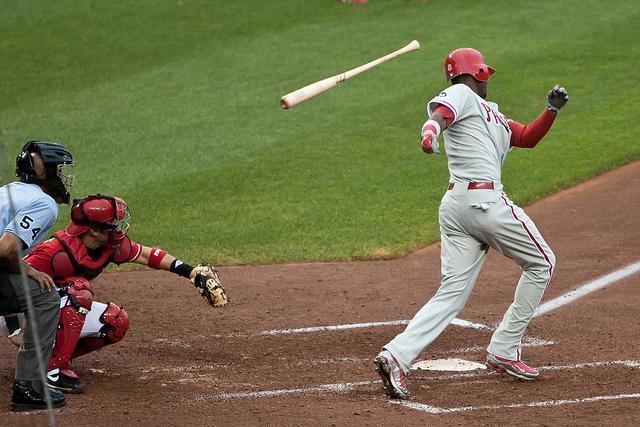How many people can you see?
Give a very brief answer. 3. 